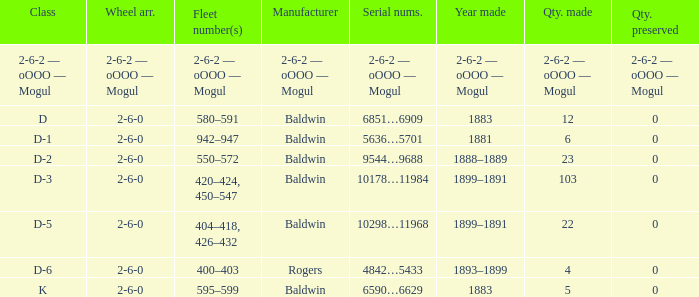What is the year made when the manufacturer is 2-6-2 — oooo — mogul? 2-6-2 — oOOO — Mogul. 